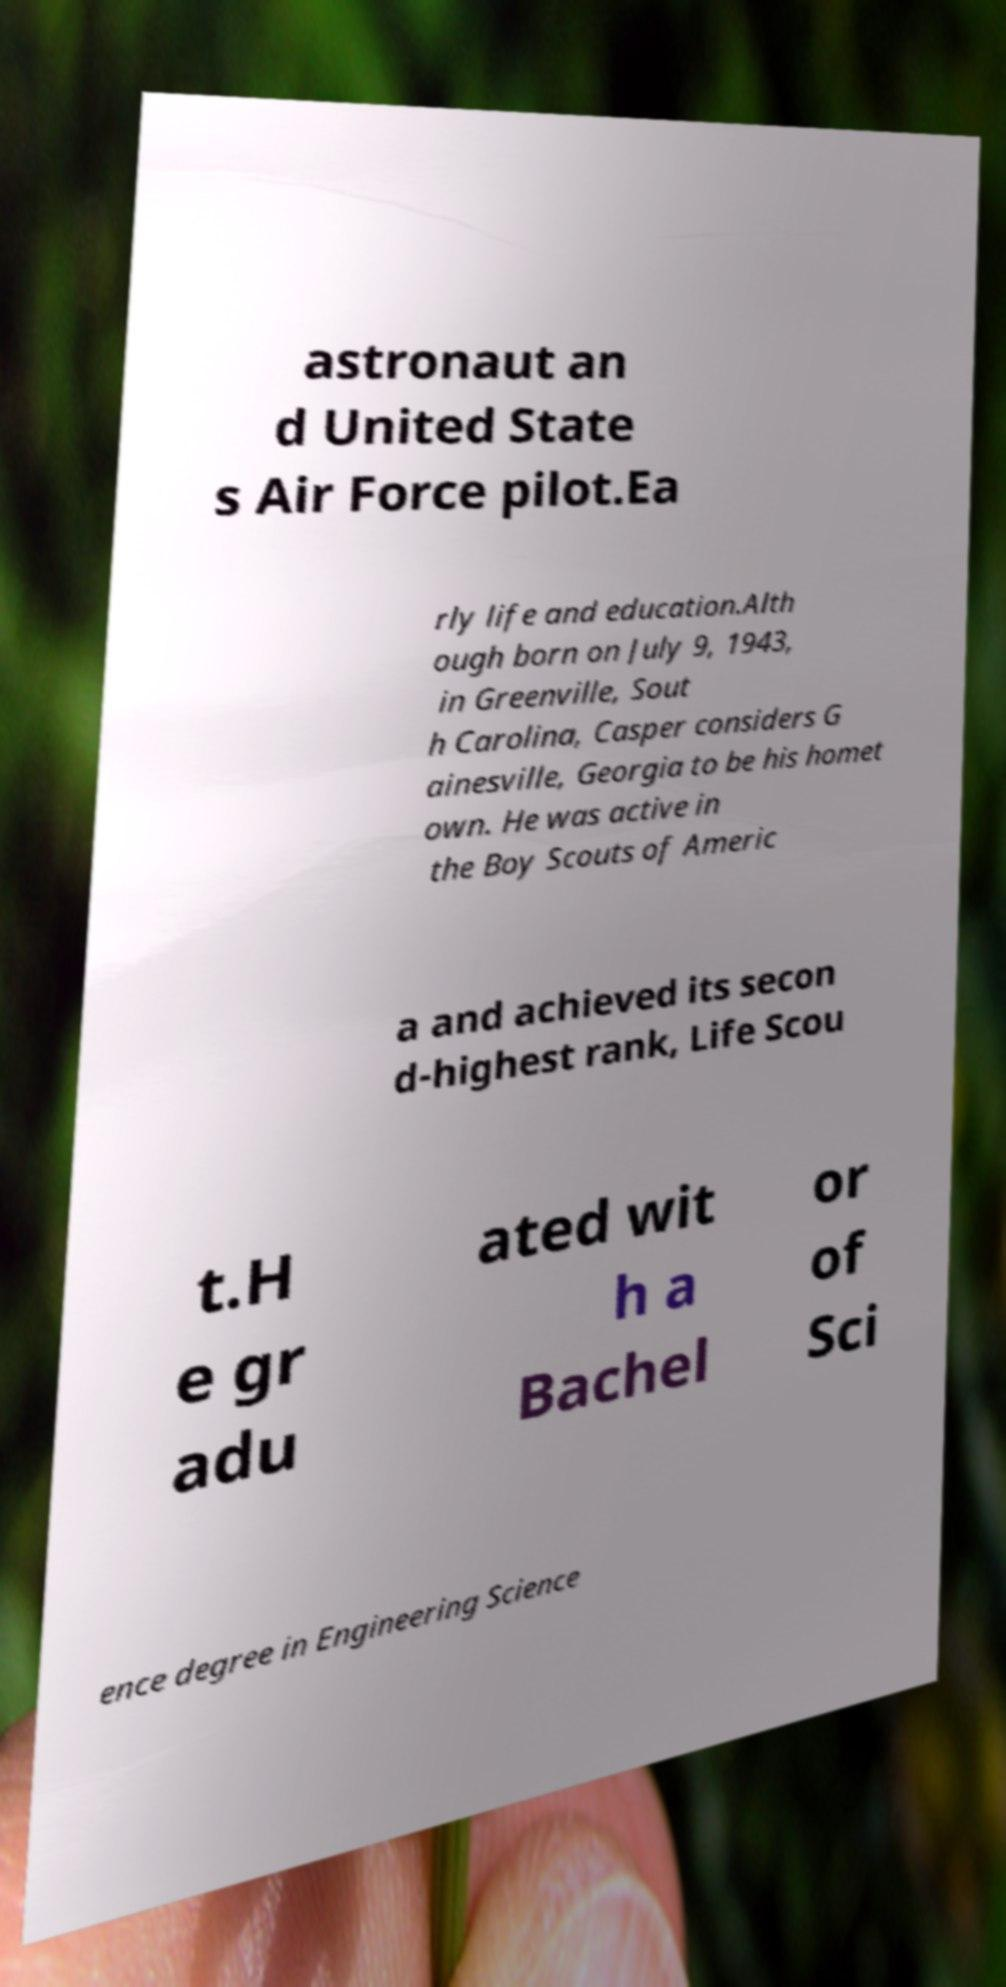Could you assist in decoding the text presented in this image and type it out clearly? astronaut an d United State s Air Force pilot.Ea rly life and education.Alth ough born on July 9, 1943, in Greenville, Sout h Carolina, Casper considers G ainesville, Georgia to be his homet own. He was active in the Boy Scouts of Americ a and achieved its secon d-highest rank, Life Scou t.H e gr adu ated wit h a Bachel or of Sci ence degree in Engineering Science 